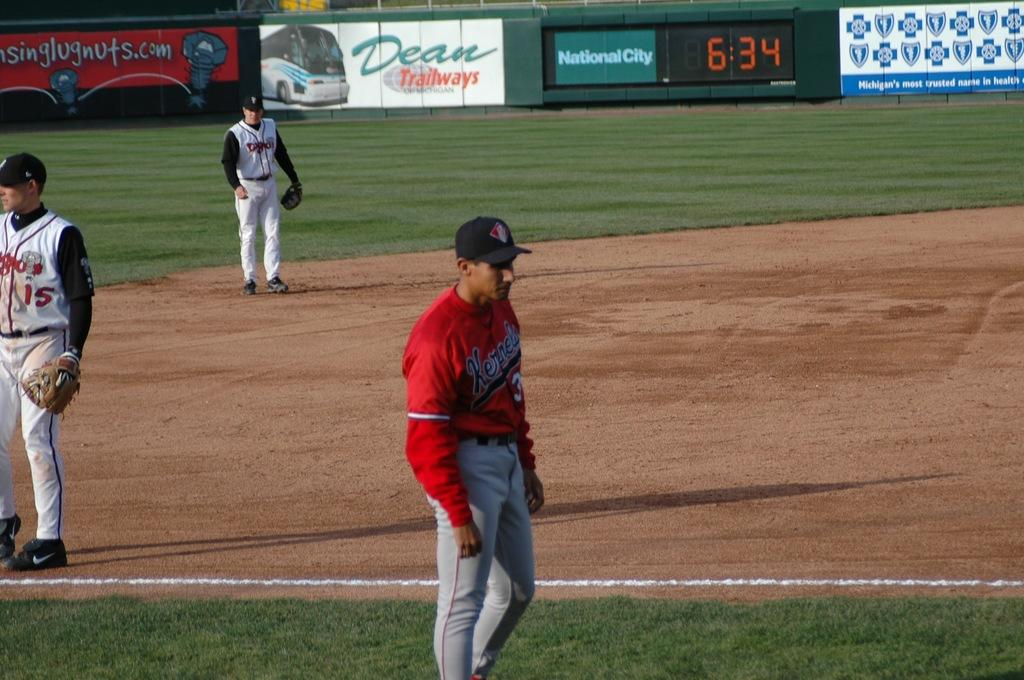<image>
Present a compact description of the photo's key features. The National City Advertisement displays the time as 6:34. 